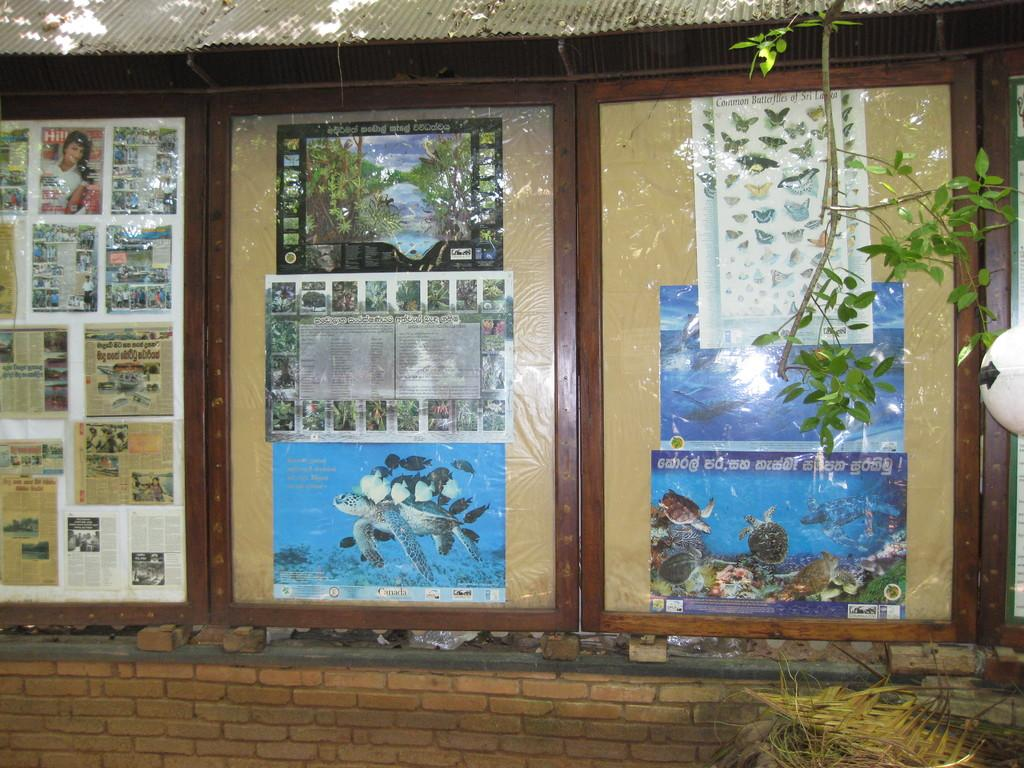What is located inside the glass in the foreground of the image? There are posters inside the glass in the foreground of the image. Where are the posters situated in relation to the shed? The posters are under a shed. What can be seen at the bottom of the image? There is a wall at the bottom of the image. What type of natural environment is visible on the right side of the image? There is greenery on the right side of the image. How many birds are sitting on the family in the image? There are no birds or family members present in the image; it features posters under a shed with a wall at the bottom and greenery on the right side. 